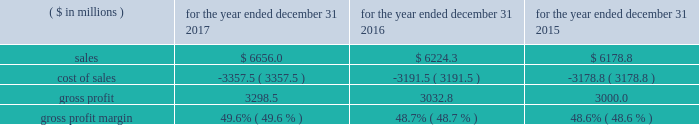2022 higher 2017 sales volumes , incremental year-over-year cost savings associated with restructuring and productivity improvement initiatives , costs associated with various growth investments made in 2016 and changes in currency exchange rates , partially offset by incremental year-over-year costs associated with various product development and sales and marketing growth investments : 60 basis points year-over-year operating profit margin comparisons were unfavorably impacted by : 2022 the incremental year-over-year net dilutive effect of acquired businesses : 20 basis points 2016 compared to 2015 year-over-year price increases in the segment contributed 0.3% ( 0.3 % ) to sales growth during 2016 as compared to 2015 and are reflected as a component of the change in sales from existing businesses .
Sales from existing businesses in the segment 2019s transportation technologies businesses grew at a high-single digit rate during 2016 as compared to 2015 , due primarily to strong demand for dispenser , payment and point-of-sale systems , environmental compliance products as well as vehicle and fleet management products , partly offset by weaker year-over-year demand for compressed natural gas products .
As expected , beginning in the second half of 2016 , the business began to experience reduced emv-related demand for indoor point-of-sale solutions , as customers had largely upgraded to products that support indoor emv requirements in the prior year in response to the indoor liability shift .
However , demand increased on a year-over-year basis for dispensers and payment systems as customers in the united states continued to upgrade equipment driven primarily by the emv deadlines related to outdoor payment systems .
Geographically , sales from existing businesses continued to increase on a year-over-year basis in the united states and to a lesser extent in asia and western europe .
Sales from existing businesses in the segment 2019s automation & specialty components business declined at a low-single digit rate during 2016 as compared to 2015 .
The businesses experienced sequential year-over-year improvement in demand during the second half of 2016 as compared to the first half of 2016 .
During 2016 , year-over-year demand declined for engine retarder products due primarily to weakness in the north american heavy-truck market , partly offset by strong growth in china and europe .
In addition , year-over-year demand declined in certain medical and defense related end markets which were partly offset by increased year-over-year demand for industrial automation products particularly in china .
Geographically , sales from existing businesses in the segment 2019s automation & specialty components businesses declined in north america , partly offset by growth in western europe and china .
Sales from existing businesses in the segment 2019s franchise distribution business grew at a mid-single digit rate during 2016 , as compared to 2015 , due primarily to continued net increases in franchisees as well as continued growth in demand for professional tool products and tool storage products , primarily in the united states .
This growth was partly offset by year- over-year declines in wheel service equipment sales during 2016 .
Operating profit margins increased 70 basis points during 2016 as compared to 2015 .
The following factors favorably impacted year-over-year operating profit margin comparisons : 2022 higher 2016 sales volumes , pricing improvements , incremental year-over-year cost savings associated with restructuring and productivity improvement initiatives and the incrementally favorable impact of the impairment of certain tradenames used in the segment in 2015 and 2016 , net of costs associated with various growth investments , product development and sales and marketing growth investments , higher year-over-year costs associated with restructuring actions and changes in currency exchange rates : 65 basis points 2022 the incremental net accretive effect in 2016 of acquired businesses : 5 basis points cost of sales and gross profit .
The year-over-year increase in cost of sales during 2017 as compared to 2016 is due primarily to the impact of higher year- over-year sales volumes and changes in currency exchange rates partly offset by incremental year-over-year cost savings .
What was the percentage change in sales from 2016 to 2017? 
Computations: ((6656.0 - 6224.3) / 6224.3)
Answer: 0.06936. 